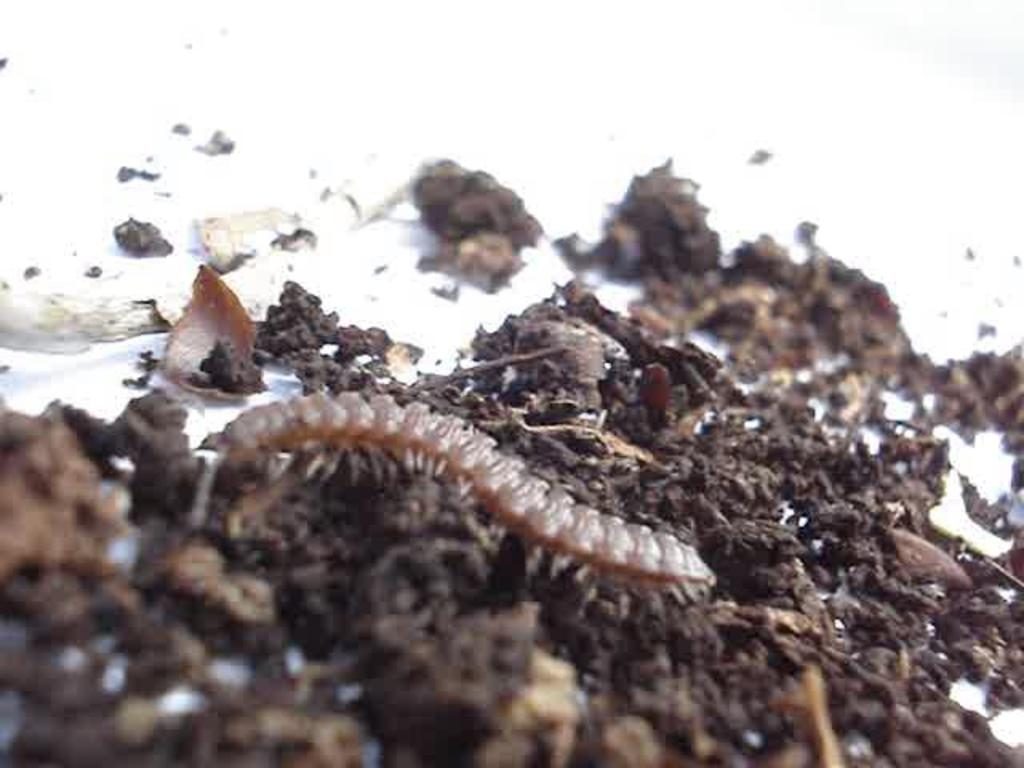What type of insect can be seen in the image? There is an insect in the image, and it is brown in color. What is the insect resting on in the image? The insect is on mud in the image. What is the background color of the mud in the image? The mud is on a white surface in the image. What type of plants can be seen growing in the image? There are no plants visible in the image; it only shows an insect on mud on a white surface. What kind of noise can be heard coming from the insect in the image? Insects do not make noise that can be heard in images, as images are silent. 